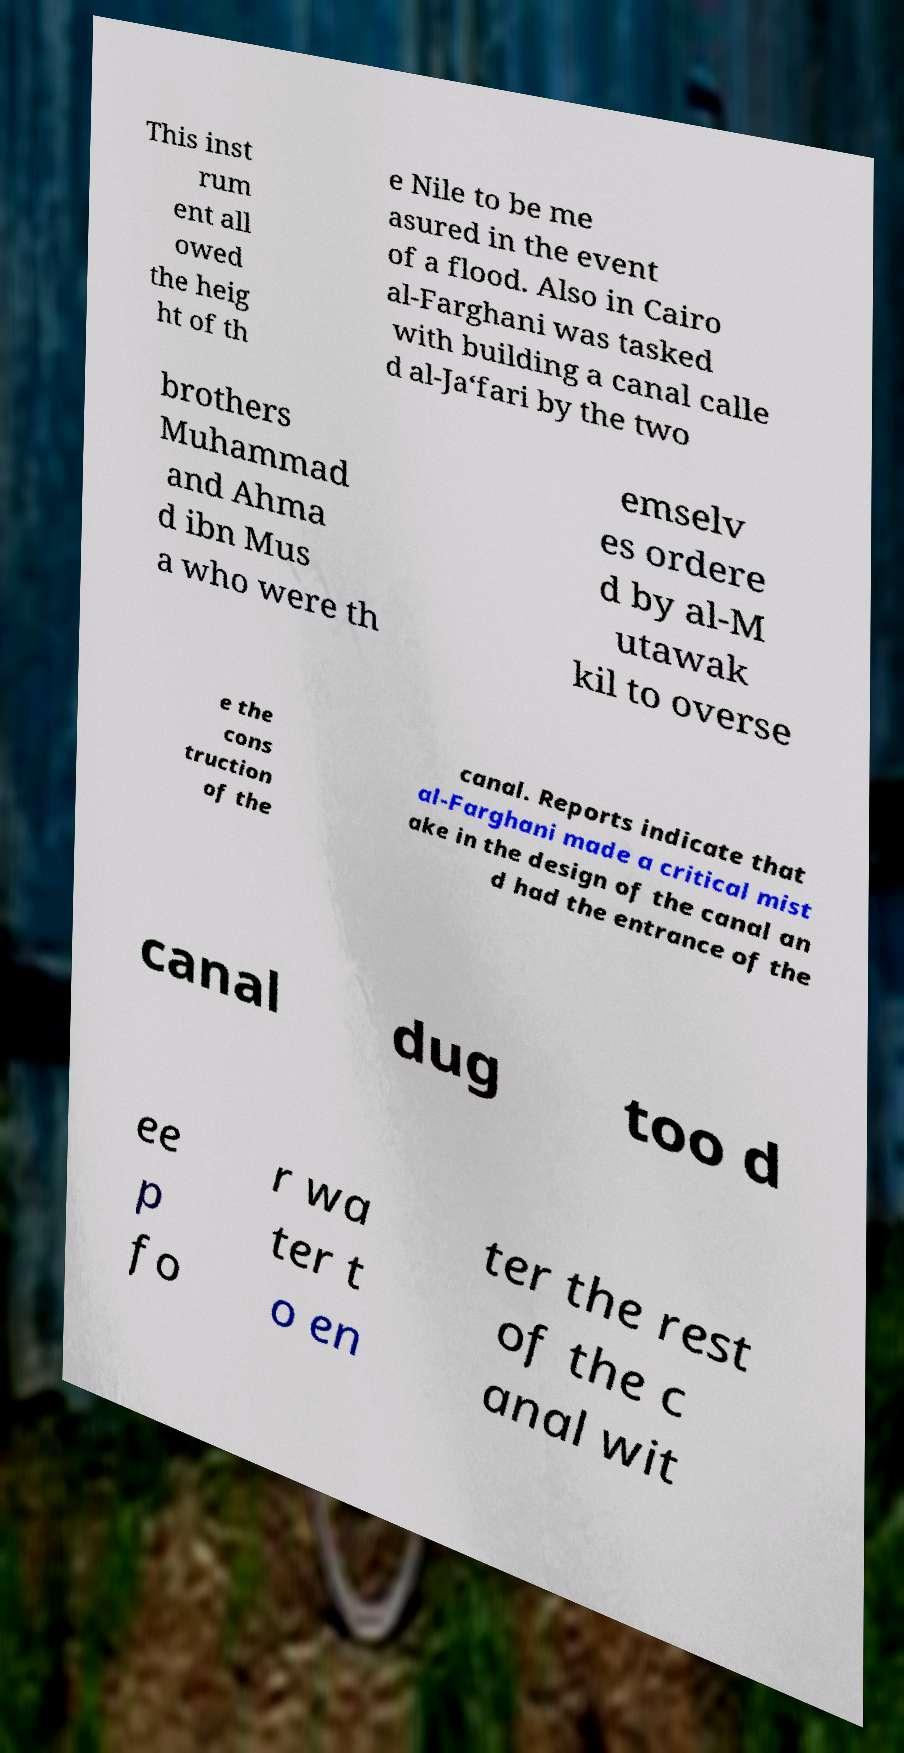For documentation purposes, I need the text within this image transcribed. Could you provide that? This inst rum ent all owed the heig ht of th e Nile to be me asured in the event of a flood. Also in Cairo al-Farghani was tasked with building a canal calle d al-Ja‘fari by the two brothers Muhammad and Ahma d ibn Mus a who were th emselv es ordere d by al-M utawak kil to overse e the cons truction of the canal. Reports indicate that al-Farghani made a critical mist ake in the design of the canal an d had the entrance of the canal dug too d ee p fo r wa ter t o en ter the rest of the c anal wit 